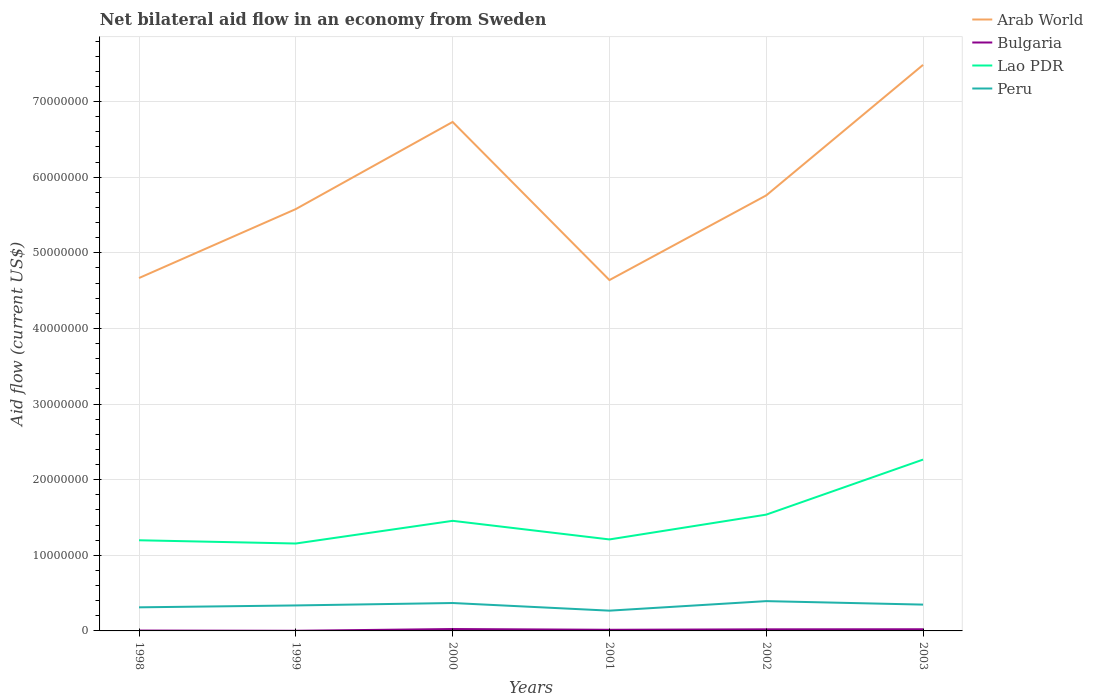How many different coloured lines are there?
Your answer should be very brief. 4. Does the line corresponding to Arab World intersect with the line corresponding to Lao PDR?
Provide a succinct answer. No. Is the number of lines equal to the number of legend labels?
Ensure brevity in your answer.  Yes. Across all years, what is the maximum net bilateral aid flow in Bulgaria?
Offer a terse response. 2.00e+04. What is the total net bilateral aid flow in Lao PDR in the graph?
Make the answer very short. -2.57e+06. What is the difference between the highest and the second highest net bilateral aid flow in Peru?
Give a very brief answer. 1.26e+06. What is the difference between the highest and the lowest net bilateral aid flow in Arab World?
Your response must be concise. 2. Is the net bilateral aid flow in Arab World strictly greater than the net bilateral aid flow in Peru over the years?
Your answer should be compact. No. How many lines are there?
Make the answer very short. 4. What is the difference between two consecutive major ticks on the Y-axis?
Offer a very short reply. 1.00e+07. Are the values on the major ticks of Y-axis written in scientific E-notation?
Your response must be concise. No. Does the graph contain grids?
Your answer should be compact. Yes. Where does the legend appear in the graph?
Ensure brevity in your answer.  Top right. How are the legend labels stacked?
Keep it short and to the point. Vertical. What is the title of the graph?
Offer a very short reply. Net bilateral aid flow in an economy from Sweden. Does "Sri Lanka" appear as one of the legend labels in the graph?
Provide a short and direct response. No. What is the label or title of the Y-axis?
Offer a very short reply. Aid flow (current US$). What is the Aid flow (current US$) in Arab World in 1998?
Offer a very short reply. 4.67e+07. What is the Aid flow (current US$) of Lao PDR in 1998?
Provide a short and direct response. 1.20e+07. What is the Aid flow (current US$) in Peru in 1998?
Offer a very short reply. 3.12e+06. What is the Aid flow (current US$) of Arab World in 1999?
Offer a very short reply. 5.58e+07. What is the Aid flow (current US$) in Lao PDR in 1999?
Your answer should be very brief. 1.16e+07. What is the Aid flow (current US$) in Peru in 1999?
Keep it short and to the point. 3.37e+06. What is the Aid flow (current US$) of Arab World in 2000?
Provide a succinct answer. 6.73e+07. What is the Aid flow (current US$) in Bulgaria in 2000?
Offer a very short reply. 2.50e+05. What is the Aid flow (current US$) in Lao PDR in 2000?
Your response must be concise. 1.46e+07. What is the Aid flow (current US$) of Peru in 2000?
Offer a very short reply. 3.69e+06. What is the Aid flow (current US$) in Arab World in 2001?
Give a very brief answer. 4.64e+07. What is the Aid flow (current US$) in Lao PDR in 2001?
Your answer should be very brief. 1.21e+07. What is the Aid flow (current US$) in Peru in 2001?
Offer a very short reply. 2.68e+06. What is the Aid flow (current US$) of Arab World in 2002?
Offer a terse response. 5.76e+07. What is the Aid flow (current US$) in Lao PDR in 2002?
Give a very brief answer. 1.54e+07. What is the Aid flow (current US$) of Peru in 2002?
Your answer should be compact. 3.94e+06. What is the Aid flow (current US$) of Arab World in 2003?
Give a very brief answer. 7.49e+07. What is the Aid flow (current US$) in Lao PDR in 2003?
Offer a very short reply. 2.27e+07. What is the Aid flow (current US$) of Peru in 2003?
Keep it short and to the point. 3.48e+06. Across all years, what is the maximum Aid flow (current US$) in Arab World?
Offer a terse response. 7.49e+07. Across all years, what is the maximum Aid flow (current US$) of Bulgaria?
Provide a short and direct response. 2.50e+05. Across all years, what is the maximum Aid flow (current US$) of Lao PDR?
Your response must be concise. 2.27e+07. Across all years, what is the maximum Aid flow (current US$) in Peru?
Offer a very short reply. 3.94e+06. Across all years, what is the minimum Aid flow (current US$) in Arab World?
Your answer should be compact. 4.64e+07. Across all years, what is the minimum Aid flow (current US$) of Bulgaria?
Your answer should be compact. 2.00e+04. Across all years, what is the minimum Aid flow (current US$) of Lao PDR?
Ensure brevity in your answer.  1.16e+07. Across all years, what is the minimum Aid flow (current US$) in Peru?
Keep it short and to the point. 2.68e+06. What is the total Aid flow (current US$) in Arab World in the graph?
Ensure brevity in your answer.  3.49e+08. What is the total Aid flow (current US$) in Bulgaria in the graph?
Give a very brief answer. 9.00e+05. What is the total Aid flow (current US$) of Lao PDR in the graph?
Offer a very short reply. 8.82e+07. What is the total Aid flow (current US$) of Peru in the graph?
Give a very brief answer. 2.03e+07. What is the difference between the Aid flow (current US$) in Arab World in 1998 and that in 1999?
Make the answer very short. -9.12e+06. What is the difference between the Aid flow (current US$) in Bulgaria in 1998 and that in 1999?
Offer a terse response. 3.00e+04. What is the difference between the Aid flow (current US$) of Lao PDR in 1998 and that in 1999?
Provide a short and direct response. 4.30e+05. What is the difference between the Aid flow (current US$) of Peru in 1998 and that in 1999?
Provide a succinct answer. -2.50e+05. What is the difference between the Aid flow (current US$) in Arab World in 1998 and that in 2000?
Ensure brevity in your answer.  -2.06e+07. What is the difference between the Aid flow (current US$) in Bulgaria in 1998 and that in 2000?
Offer a very short reply. -2.00e+05. What is the difference between the Aid flow (current US$) of Lao PDR in 1998 and that in 2000?
Give a very brief answer. -2.57e+06. What is the difference between the Aid flow (current US$) in Peru in 1998 and that in 2000?
Offer a very short reply. -5.70e+05. What is the difference between the Aid flow (current US$) of Lao PDR in 1998 and that in 2001?
Your answer should be very brief. -1.10e+05. What is the difference between the Aid flow (current US$) of Arab World in 1998 and that in 2002?
Your answer should be very brief. -1.09e+07. What is the difference between the Aid flow (current US$) of Lao PDR in 1998 and that in 2002?
Offer a very short reply. -3.39e+06. What is the difference between the Aid flow (current US$) in Peru in 1998 and that in 2002?
Keep it short and to the point. -8.20e+05. What is the difference between the Aid flow (current US$) of Arab World in 1998 and that in 2003?
Provide a succinct answer. -2.82e+07. What is the difference between the Aid flow (current US$) in Bulgaria in 1998 and that in 2003?
Provide a short and direct response. -1.70e+05. What is the difference between the Aid flow (current US$) in Lao PDR in 1998 and that in 2003?
Your response must be concise. -1.07e+07. What is the difference between the Aid flow (current US$) in Peru in 1998 and that in 2003?
Offer a very short reply. -3.60e+05. What is the difference between the Aid flow (current US$) of Arab World in 1999 and that in 2000?
Your answer should be compact. -1.15e+07. What is the difference between the Aid flow (current US$) of Lao PDR in 1999 and that in 2000?
Offer a very short reply. -3.00e+06. What is the difference between the Aid flow (current US$) in Peru in 1999 and that in 2000?
Provide a short and direct response. -3.20e+05. What is the difference between the Aid flow (current US$) in Arab World in 1999 and that in 2001?
Make the answer very short. 9.39e+06. What is the difference between the Aid flow (current US$) of Lao PDR in 1999 and that in 2001?
Your response must be concise. -5.40e+05. What is the difference between the Aid flow (current US$) in Peru in 1999 and that in 2001?
Give a very brief answer. 6.90e+05. What is the difference between the Aid flow (current US$) in Arab World in 1999 and that in 2002?
Keep it short and to the point. -1.81e+06. What is the difference between the Aid flow (current US$) of Lao PDR in 1999 and that in 2002?
Give a very brief answer. -3.82e+06. What is the difference between the Aid flow (current US$) of Peru in 1999 and that in 2002?
Provide a succinct answer. -5.70e+05. What is the difference between the Aid flow (current US$) in Arab World in 1999 and that in 2003?
Keep it short and to the point. -1.91e+07. What is the difference between the Aid flow (current US$) in Bulgaria in 1999 and that in 2003?
Your response must be concise. -2.00e+05. What is the difference between the Aid flow (current US$) in Lao PDR in 1999 and that in 2003?
Offer a very short reply. -1.11e+07. What is the difference between the Aid flow (current US$) of Arab World in 2000 and that in 2001?
Your answer should be compact. 2.09e+07. What is the difference between the Aid flow (current US$) in Bulgaria in 2000 and that in 2001?
Keep it short and to the point. 1.00e+05. What is the difference between the Aid flow (current US$) of Lao PDR in 2000 and that in 2001?
Offer a very short reply. 2.46e+06. What is the difference between the Aid flow (current US$) of Peru in 2000 and that in 2001?
Offer a terse response. 1.01e+06. What is the difference between the Aid flow (current US$) in Arab World in 2000 and that in 2002?
Ensure brevity in your answer.  9.71e+06. What is the difference between the Aid flow (current US$) in Bulgaria in 2000 and that in 2002?
Keep it short and to the point. 4.00e+04. What is the difference between the Aid flow (current US$) of Lao PDR in 2000 and that in 2002?
Offer a very short reply. -8.20e+05. What is the difference between the Aid flow (current US$) of Arab World in 2000 and that in 2003?
Your answer should be compact. -7.55e+06. What is the difference between the Aid flow (current US$) in Bulgaria in 2000 and that in 2003?
Give a very brief answer. 3.00e+04. What is the difference between the Aid flow (current US$) of Lao PDR in 2000 and that in 2003?
Your answer should be compact. -8.10e+06. What is the difference between the Aid flow (current US$) of Arab World in 2001 and that in 2002?
Make the answer very short. -1.12e+07. What is the difference between the Aid flow (current US$) in Bulgaria in 2001 and that in 2002?
Keep it short and to the point. -6.00e+04. What is the difference between the Aid flow (current US$) in Lao PDR in 2001 and that in 2002?
Your answer should be compact. -3.28e+06. What is the difference between the Aid flow (current US$) of Peru in 2001 and that in 2002?
Your answer should be compact. -1.26e+06. What is the difference between the Aid flow (current US$) of Arab World in 2001 and that in 2003?
Keep it short and to the point. -2.85e+07. What is the difference between the Aid flow (current US$) in Bulgaria in 2001 and that in 2003?
Your response must be concise. -7.00e+04. What is the difference between the Aid flow (current US$) of Lao PDR in 2001 and that in 2003?
Your response must be concise. -1.06e+07. What is the difference between the Aid flow (current US$) in Peru in 2001 and that in 2003?
Your response must be concise. -8.00e+05. What is the difference between the Aid flow (current US$) in Arab World in 2002 and that in 2003?
Give a very brief answer. -1.73e+07. What is the difference between the Aid flow (current US$) in Bulgaria in 2002 and that in 2003?
Your answer should be very brief. -10000. What is the difference between the Aid flow (current US$) of Lao PDR in 2002 and that in 2003?
Provide a succinct answer. -7.28e+06. What is the difference between the Aid flow (current US$) in Arab World in 1998 and the Aid flow (current US$) in Bulgaria in 1999?
Your response must be concise. 4.66e+07. What is the difference between the Aid flow (current US$) of Arab World in 1998 and the Aid flow (current US$) of Lao PDR in 1999?
Offer a very short reply. 3.51e+07. What is the difference between the Aid flow (current US$) of Arab World in 1998 and the Aid flow (current US$) of Peru in 1999?
Provide a short and direct response. 4.33e+07. What is the difference between the Aid flow (current US$) of Bulgaria in 1998 and the Aid flow (current US$) of Lao PDR in 1999?
Give a very brief answer. -1.15e+07. What is the difference between the Aid flow (current US$) in Bulgaria in 1998 and the Aid flow (current US$) in Peru in 1999?
Offer a very short reply. -3.32e+06. What is the difference between the Aid flow (current US$) of Lao PDR in 1998 and the Aid flow (current US$) of Peru in 1999?
Your answer should be compact. 8.62e+06. What is the difference between the Aid flow (current US$) in Arab World in 1998 and the Aid flow (current US$) in Bulgaria in 2000?
Offer a very short reply. 4.64e+07. What is the difference between the Aid flow (current US$) in Arab World in 1998 and the Aid flow (current US$) in Lao PDR in 2000?
Keep it short and to the point. 3.21e+07. What is the difference between the Aid flow (current US$) of Arab World in 1998 and the Aid flow (current US$) of Peru in 2000?
Make the answer very short. 4.30e+07. What is the difference between the Aid flow (current US$) of Bulgaria in 1998 and the Aid flow (current US$) of Lao PDR in 2000?
Provide a short and direct response. -1.45e+07. What is the difference between the Aid flow (current US$) in Bulgaria in 1998 and the Aid flow (current US$) in Peru in 2000?
Ensure brevity in your answer.  -3.64e+06. What is the difference between the Aid flow (current US$) in Lao PDR in 1998 and the Aid flow (current US$) in Peru in 2000?
Make the answer very short. 8.30e+06. What is the difference between the Aid flow (current US$) in Arab World in 1998 and the Aid flow (current US$) in Bulgaria in 2001?
Ensure brevity in your answer.  4.65e+07. What is the difference between the Aid flow (current US$) of Arab World in 1998 and the Aid flow (current US$) of Lao PDR in 2001?
Your answer should be compact. 3.46e+07. What is the difference between the Aid flow (current US$) in Arab World in 1998 and the Aid flow (current US$) in Peru in 2001?
Provide a succinct answer. 4.40e+07. What is the difference between the Aid flow (current US$) of Bulgaria in 1998 and the Aid flow (current US$) of Lao PDR in 2001?
Offer a terse response. -1.20e+07. What is the difference between the Aid flow (current US$) of Bulgaria in 1998 and the Aid flow (current US$) of Peru in 2001?
Your answer should be compact. -2.63e+06. What is the difference between the Aid flow (current US$) of Lao PDR in 1998 and the Aid flow (current US$) of Peru in 2001?
Make the answer very short. 9.31e+06. What is the difference between the Aid flow (current US$) in Arab World in 1998 and the Aid flow (current US$) in Bulgaria in 2002?
Offer a very short reply. 4.65e+07. What is the difference between the Aid flow (current US$) in Arab World in 1998 and the Aid flow (current US$) in Lao PDR in 2002?
Provide a short and direct response. 3.13e+07. What is the difference between the Aid flow (current US$) of Arab World in 1998 and the Aid flow (current US$) of Peru in 2002?
Offer a terse response. 4.27e+07. What is the difference between the Aid flow (current US$) of Bulgaria in 1998 and the Aid flow (current US$) of Lao PDR in 2002?
Offer a terse response. -1.53e+07. What is the difference between the Aid flow (current US$) in Bulgaria in 1998 and the Aid flow (current US$) in Peru in 2002?
Provide a short and direct response. -3.89e+06. What is the difference between the Aid flow (current US$) of Lao PDR in 1998 and the Aid flow (current US$) of Peru in 2002?
Offer a very short reply. 8.05e+06. What is the difference between the Aid flow (current US$) of Arab World in 1998 and the Aid flow (current US$) of Bulgaria in 2003?
Your answer should be compact. 4.64e+07. What is the difference between the Aid flow (current US$) of Arab World in 1998 and the Aid flow (current US$) of Lao PDR in 2003?
Keep it short and to the point. 2.40e+07. What is the difference between the Aid flow (current US$) of Arab World in 1998 and the Aid flow (current US$) of Peru in 2003?
Provide a short and direct response. 4.32e+07. What is the difference between the Aid flow (current US$) in Bulgaria in 1998 and the Aid flow (current US$) in Lao PDR in 2003?
Your answer should be very brief. -2.26e+07. What is the difference between the Aid flow (current US$) in Bulgaria in 1998 and the Aid flow (current US$) in Peru in 2003?
Keep it short and to the point. -3.43e+06. What is the difference between the Aid flow (current US$) of Lao PDR in 1998 and the Aid flow (current US$) of Peru in 2003?
Make the answer very short. 8.51e+06. What is the difference between the Aid flow (current US$) in Arab World in 1999 and the Aid flow (current US$) in Bulgaria in 2000?
Offer a terse response. 5.55e+07. What is the difference between the Aid flow (current US$) in Arab World in 1999 and the Aid flow (current US$) in Lao PDR in 2000?
Provide a short and direct response. 4.12e+07. What is the difference between the Aid flow (current US$) of Arab World in 1999 and the Aid flow (current US$) of Peru in 2000?
Offer a terse response. 5.21e+07. What is the difference between the Aid flow (current US$) in Bulgaria in 1999 and the Aid flow (current US$) in Lao PDR in 2000?
Provide a succinct answer. -1.45e+07. What is the difference between the Aid flow (current US$) of Bulgaria in 1999 and the Aid flow (current US$) of Peru in 2000?
Provide a short and direct response. -3.67e+06. What is the difference between the Aid flow (current US$) of Lao PDR in 1999 and the Aid flow (current US$) of Peru in 2000?
Your answer should be very brief. 7.87e+06. What is the difference between the Aid flow (current US$) of Arab World in 1999 and the Aid flow (current US$) of Bulgaria in 2001?
Provide a succinct answer. 5.56e+07. What is the difference between the Aid flow (current US$) of Arab World in 1999 and the Aid flow (current US$) of Lao PDR in 2001?
Offer a very short reply. 4.37e+07. What is the difference between the Aid flow (current US$) of Arab World in 1999 and the Aid flow (current US$) of Peru in 2001?
Offer a terse response. 5.31e+07. What is the difference between the Aid flow (current US$) in Bulgaria in 1999 and the Aid flow (current US$) in Lao PDR in 2001?
Offer a terse response. -1.21e+07. What is the difference between the Aid flow (current US$) of Bulgaria in 1999 and the Aid flow (current US$) of Peru in 2001?
Your answer should be compact. -2.66e+06. What is the difference between the Aid flow (current US$) in Lao PDR in 1999 and the Aid flow (current US$) in Peru in 2001?
Offer a very short reply. 8.88e+06. What is the difference between the Aid flow (current US$) in Arab World in 1999 and the Aid flow (current US$) in Bulgaria in 2002?
Your response must be concise. 5.56e+07. What is the difference between the Aid flow (current US$) of Arab World in 1999 and the Aid flow (current US$) of Lao PDR in 2002?
Give a very brief answer. 4.04e+07. What is the difference between the Aid flow (current US$) of Arab World in 1999 and the Aid flow (current US$) of Peru in 2002?
Offer a very short reply. 5.18e+07. What is the difference between the Aid flow (current US$) in Bulgaria in 1999 and the Aid flow (current US$) in Lao PDR in 2002?
Give a very brief answer. -1.54e+07. What is the difference between the Aid flow (current US$) of Bulgaria in 1999 and the Aid flow (current US$) of Peru in 2002?
Offer a very short reply. -3.92e+06. What is the difference between the Aid flow (current US$) in Lao PDR in 1999 and the Aid flow (current US$) in Peru in 2002?
Your answer should be compact. 7.62e+06. What is the difference between the Aid flow (current US$) in Arab World in 1999 and the Aid flow (current US$) in Bulgaria in 2003?
Give a very brief answer. 5.56e+07. What is the difference between the Aid flow (current US$) of Arab World in 1999 and the Aid flow (current US$) of Lao PDR in 2003?
Ensure brevity in your answer.  3.31e+07. What is the difference between the Aid flow (current US$) in Arab World in 1999 and the Aid flow (current US$) in Peru in 2003?
Offer a very short reply. 5.23e+07. What is the difference between the Aid flow (current US$) in Bulgaria in 1999 and the Aid flow (current US$) in Lao PDR in 2003?
Your answer should be compact. -2.26e+07. What is the difference between the Aid flow (current US$) of Bulgaria in 1999 and the Aid flow (current US$) of Peru in 2003?
Your response must be concise. -3.46e+06. What is the difference between the Aid flow (current US$) in Lao PDR in 1999 and the Aid flow (current US$) in Peru in 2003?
Provide a short and direct response. 8.08e+06. What is the difference between the Aid flow (current US$) of Arab World in 2000 and the Aid flow (current US$) of Bulgaria in 2001?
Your answer should be compact. 6.72e+07. What is the difference between the Aid flow (current US$) of Arab World in 2000 and the Aid flow (current US$) of Lao PDR in 2001?
Give a very brief answer. 5.52e+07. What is the difference between the Aid flow (current US$) of Arab World in 2000 and the Aid flow (current US$) of Peru in 2001?
Ensure brevity in your answer.  6.46e+07. What is the difference between the Aid flow (current US$) in Bulgaria in 2000 and the Aid flow (current US$) in Lao PDR in 2001?
Your answer should be compact. -1.18e+07. What is the difference between the Aid flow (current US$) of Bulgaria in 2000 and the Aid flow (current US$) of Peru in 2001?
Provide a short and direct response. -2.43e+06. What is the difference between the Aid flow (current US$) in Lao PDR in 2000 and the Aid flow (current US$) in Peru in 2001?
Ensure brevity in your answer.  1.19e+07. What is the difference between the Aid flow (current US$) of Arab World in 2000 and the Aid flow (current US$) of Bulgaria in 2002?
Provide a short and direct response. 6.71e+07. What is the difference between the Aid flow (current US$) of Arab World in 2000 and the Aid flow (current US$) of Lao PDR in 2002?
Give a very brief answer. 5.19e+07. What is the difference between the Aid flow (current US$) in Arab World in 2000 and the Aid flow (current US$) in Peru in 2002?
Make the answer very short. 6.34e+07. What is the difference between the Aid flow (current US$) in Bulgaria in 2000 and the Aid flow (current US$) in Lao PDR in 2002?
Give a very brief answer. -1.51e+07. What is the difference between the Aid flow (current US$) of Bulgaria in 2000 and the Aid flow (current US$) of Peru in 2002?
Offer a very short reply. -3.69e+06. What is the difference between the Aid flow (current US$) of Lao PDR in 2000 and the Aid flow (current US$) of Peru in 2002?
Provide a short and direct response. 1.06e+07. What is the difference between the Aid flow (current US$) in Arab World in 2000 and the Aid flow (current US$) in Bulgaria in 2003?
Ensure brevity in your answer.  6.71e+07. What is the difference between the Aid flow (current US$) in Arab World in 2000 and the Aid flow (current US$) in Lao PDR in 2003?
Offer a terse response. 4.46e+07. What is the difference between the Aid flow (current US$) in Arab World in 2000 and the Aid flow (current US$) in Peru in 2003?
Provide a short and direct response. 6.38e+07. What is the difference between the Aid flow (current US$) of Bulgaria in 2000 and the Aid flow (current US$) of Lao PDR in 2003?
Make the answer very short. -2.24e+07. What is the difference between the Aid flow (current US$) of Bulgaria in 2000 and the Aid flow (current US$) of Peru in 2003?
Ensure brevity in your answer.  -3.23e+06. What is the difference between the Aid flow (current US$) of Lao PDR in 2000 and the Aid flow (current US$) of Peru in 2003?
Keep it short and to the point. 1.11e+07. What is the difference between the Aid flow (current US$) of Arab World in 2001 and the Aid flow (current US$) of Bulgaria in 2002?
Provide a short and direct response. 4.62e+07. What is the difference between the Aid flow (current US$) of Arab World in 2001 and the Aid flow (current US$) of Lao PDR in 2002?
Make the answer very short. 3.10e+07. What is the difference between the Aid flow (current US$) in Arab World in 2001 and the Aid flow (current US$) in Peru in 2002?
Your answer should be compact. 4.25e+07. What is the difference between the Aid flow (current US$) in Bulgaria in 2001 and the Aid flow (current US$) in Lao PDR in 2002?
Offer a terse response. -1.52e+07. What is the difference between the Aid flow (current US$) of Bulgaria in 2001 and the Aid flow (current US$) of Peru in 2002?
Provide a short and direct response. -3.79e+06. What is the difference between the Aid flow (current US$) of Lao PDR in 2001 and the Aid flow (current US$) of Peru in 2002?
Provide a succinct answer. 8.16e+06. What is the difference between the Aid flow (current US$) in Arab World in 2001 and the Aid flow (current US$) in Bulgaria in 2003?
Provide a short and direct response. 4.62e+07. What is the difference between the Aid flow (current US$) of Arab World in 2001 and the Aid flow (current US$) of Lao PDR in 2003?
Give a very brief answer. 2.37e+07. What is the difference between the Aid flow (current US$) in Arab World in 2001 and the Aid flow (current US$) in Peru in 2003?
Offer a very short reply. 4.29e+07. What is the difference between the Aid flow (current US$) of Bulgaria in 2001 and the Aid flow (current US$) of Lao PDR in 2003?
Offer a very short reply. -2.25e+07. What is the difference between the Aid flow (current US$) of Bulgaria in 2001 and the Aid flow (current US$) of Peru in 2003?
Offer a very short reply. -3.33e+06. What is the difference between the Aid flow (current US$) of Lao PDR in 2001 and the Aid flow (current US$) of Peru in 2003?
Provide a succinct answer. 8.62e+06. What is the difference between the Aid flow (current US$) of Arab World in 2002 and the Aid flow (current US$) of Bulgaria in 2003?
Provide a succinct answer. 5.74e+07. What is the difference between the Aid flow (current US$) in Arab World in 2002 and the Aid flow (current US$) in Lao PDR in 2003?
Ensure brevity in your answer.  3.49e+07. What is the difference between the Aid flow (current US$) of Arab World in 2002 and the Aid flow (current US$) of Peru in 2003?
Provide a succinct answer. 5.41e+07. What is the difference between the Aid flow (current US$) of Bulgaria in 2002 and the Aid flow (current US$) of Lao PDR in 2003?
Keep it short and to the point. -2.24e+07. What is the difference between the Aid flow (current US$) in Bulgaria in 2002 and the Aid flow (current US$) in Peru in 2003?
Make the answer very short. -3.27e+06. What is the difference between the Aid flow (current US$) in Lao PDR in 2002 and the Aid flow (current US$) in Peru in 2003?
Offer a terse response. 1.19e+07. What is the average Aid flow (current US$) of Arab World per year?
Offer a terse response. 5.81e+07. What is the average Aid flow (current US$) of Bulgaria per year?
Provide a succinct answer. 1.50e+05. What is the average Aid flow (current US$) of Lao PDR per year?
Offer a terse response. 1.47e+07. What is the average Aid flow (current US$) of Peru per year?
Offer a terse response. 3.38e+06. In the year 1998, what is the difference between the Aid flow (current US$) in Arab World and Aid flow (current US$) in Bulgaria?
Offer a terse response. 4.66e+07. In the year 1998, what is the difference between the Aid flow (current US$) of Arab World and Aid flow (current US$) of Lao PDR?
Keep it short and to the point. 3.47e+07. In the year 1998, what is the difference between the Aid flow (current US$) of Arab World and Aid flow (current US$) of Peru?
Your answer should be compact. 4.36e+07. In the year 1998, what is the difference between the Aid flow (current US$) in Bulgaria and Aid flow (current US$) in Lao PDR?
Keep it short and to the point. -1.19e+07. In the year 1998, what is the difference between the Aid flow (current US$) in Bulgaria and Aid flow (current US$) in Peru?
Your response must be concise. -3.07e+06. In the year 1998, what is the difference between the Aid flow (current US$) of Lao PDR and Aid flow (current US$) of Peru?
Offer a very short reply. 8.87e+06. In the year 1999, what is the difference between the Aid flow (current US$) in Arab World and Aid flow (current US$) in Bulgaria?
Your answer should be compact. 5.58e+07. In the year 1999, what is the difference between the Aid flow (current US$) of Arab World and Aid flow (current US$) of Lao PDR?
Make the answer very short. 4.42e+07. In the year 1999, what is the difference between the Aid flow (current US$) in Arab World and Aid flow (current US$) in Peru?
Provide a short and direct response. 5.24e+07. In the year 1999, what is the difference between the Aid flow (current US$) of Bulgaria and Aid flow (current US$) of Lao PDR?
Offer a very short reply. -1.15e+07. In the year 1999, what is the difference between the Aid flow (current US$) of Bulgaria and Aid flow (current US$) of Peru?
Your response must be concise. -3.35e+06. In the year 1999, what is the difference between the Aid flow (current US$) in Lao PDR and Aid flow (current US$) in Peru?
Give a very brief answer. 8.19e+06. In the year 2000, what is the difference between the Aid flow (current US$) in Arab World and Aid flow (current US$) in Bulgaria?
Ensure brevity in your answer.  6.71e+07. In the year 2000, what is the difference between the Aid flow (current US$) of Arab World and Aid flow (current US$) of Lao PDR?
Provide a short and direct response. 5.28e+07. In the year 2000, what is the difference between the Aid flow (current US$) of Arab World and Aid flow (current US$) of Peru?
Make the answer very short. 6.36e+07. In the year 2000, what is the difference between the Aid flow (current US$) of Bulgaria and Aid flow (current US$) of Lao PDR?
Ensure brevity in your answer.  -1.43e+07. In the year 2000, what is the difference between the Aid flow (current US$) in Bulgaria and Aid flow (current US$) in Peru?
Your answer should be very brief. -3.44e+06. In the year 2000, what is the difference between the Aid flow (current US$) of Lao PDR and Aid flow (current US$) of Peru?
Offer a terse response. 1.09e+07. In the year 2001, what is the difference between the Aid flow (current US$) of Arab World and Aid flow (current US$) of Bulgaria?
Your response must be concise. 4.62e+07. In the year 2001, what is the difference between the Aid flow (current US$) in Arab World and Aid flow (current US$) in Lao PDR?
Provide a short and direct response. 3.43e+07. In the year 2001, what is the difference between the Aid flow (current US$) of Arab World and Aid flow (current US$) of Peru?
Give a very brief answer. 4.37e+07. In the year 2001, what is the difference between the Aid flow (current US$) in Bulgaria and Aid flow (current US$) in Lao PDR?
Give a very brief answer. -1.20e+07. In the year 2001, what is the difference between the Aid flow (current US$) in Bulgaria and Aid flow (current US$) in Peru?
Keep it short and to the point. -2.53e+06. In the year 2001, what is the difference between the Aid flow (current US$) in Lao PDR and Aid flow (current US$) in Peru?
Give a very brief answer. 9.42e+06. In the year 2002, what is the difference between the Aid flow (current US$) of Arab World and Aid flow (current US$) of Bulgaria?
Give a very brief answer. 5.74e+07. In the year 2002, what is the difference between the Aid flow (current US$) of Arab World and Aid flow (current US$) of Lao PDR?
Offer a terse response. 4.22e+07. In the year 2002, what is the difference between the Aid flow (current US$) in Arab World and Aid flow (current US$) in Peru?
Offer a very short reply. 5.37e+07. In the year 2002, what is the difference between the Aid flow (current US$) of Bulgaria and Aid flow (current US$) of Lao PDR?
Ensure brevity in your answer.  -1.52e+07. In the year 2002, what is the difference between the Aid flow (current US$) in Bulgaria and Aid flow (current US$) in Peru?
Ensure brevity in your answer.  -3.73e+06. In the year 2002, what is the difference between the Aid flow (current US$) in Lao PDR and Aid flow (current US$) in Peru?
Ensure brevity in your answer.  1.14e+07. In the year 2003, what is the difference between the Aid flow (current US$) of Arab World and Aid flow (current US$) of Bulgaria?
Offer a very short reply. 7.46e+07. In the year 2003, what is the difference between the Aid flow (current US$) of Arab World and Aid flow (current US$) of Lao PDR?
Offer a very short reply. 5.22e+07. In the year 2003, what is the difference between the Aid flow (current US$) in Arab World and Aid flow (current US$) in Peru?
Make the answer very short. 7.14e+07. In the year 2003, what is the difference between the Aid flow (current US$) in Bulgaria and Aid flow (current US$) in Lao PDR?
Your answer should be compact. -2.24e+07. In the year 2003, what is the difference between the Aid flow (current US$) of Bulgaria and Aid flow (current US$) of Peru?
Offer a terse response. -3.26e+06. In the year 2003, what is the difference between the Aid flow (current US$) of Lao PDR and Aid flow (current US$) of Peru?
Your response must be concise. 1.92e+07. What is the ratio of the Aid flow (current US$) in Arab World in 1998 to that in 1999?
Provide a succinct answer. 0.84. What is the ratio of the Aid flow (current US$) of Bulgaria in 1998 to that in 1999?
Provide a succinct answer. 2.5. What is the ratio of the Aid flow (current US$) in Lao PDR in 1998 to that in 1999?
Your answer should be compact. 1.04. What is the ratio of the Aid flow (current US$) in Peru in 1998 to that in 1999?
Your answer should be very brief. 0.93. What is the ratio of the Aid flow (current US$) of Arab World in 1998 to that in 2000?
Give a very brief answer. 0.69. What is the ratio of the Aid flow (current US$) in Bulgaria in 1998 to that in 2000?
Provide a short and direct response. 0.2. What is the ratio of the Aid flow (current US$) of Lao PDR in 1998 to that in 2000?
Provide a short and direct response. 0.82. What is the ratio of the Aid flow (current US$) of Peru in 1998 to that in 2000?
Make the answer very short. 0.85. What is the ratio of the Aid flow (current US$) of Lao PDR in 1998 to that in 2001?
Give a very brief answer. 0.99. What is the ratio of the Aid flow (current US$) of Peru in 1998 to that in 2001?
Ensure brevity in your answer.  1.16. What is the ratio of the Aid flow (current US$) of Arab World in 1998 to that in 2002?
Your response must be concise. 0.81. What is the ratio of the Aid flow (current US$) in Bulgaria in 1998 to that in 2002?
Provide a succinct answer. 0.24. What is the ratio of the Aid flow (current US$) of Lao PDR in 1998 to that in 2002?
Ensure brevity in your answer.  0.78. What is the ratio of the Aid flow (current US$) of Peru in 1998 to that in 2002?
Provide a short and direct response. 0.79. What is the ratio of the Aid flow (current US$) in Arab World in 1998 to that in 2003?
Provide a succinct answer. 0.62. What is the ratio of the Aid flow (current US$) of Bulgaria in 1998 to that in 2003?
Your response must be concise. 0.23. What is the ratio of the Aid flow (current US$) in Lao PDR in 1998 to that in 2003?
Your response must be concise. 0.53. What is the ratio of the Aid flow (current US$) in Peru in 1998 to that in 2003?
Your response must be concise. 0.9. What is the ratio of the Aid flow (current US$) of Arab World in 1999 to that in 2000?
Provide a short and direct response. 0.83. What is the ratio of the Aid flow (current US$) of Lao PDR in 1999 to that in 2000?
Keep it short and to the point. 0.79. What is the ratio of the Aid flow (current US$) of Peru in 1999 to that in 2000?
Offer a very short reply. 0.91. What is the ratio of the Aid flow (current US$) in Arab World in 1999 to that in 2001?
Keep it short and to the point. 1.2. What is the ratio of the Aid flow (current US$) in Bulgaria in 1999 to that in 2001?
Make the answer very short. 0.13. What is the ratio of the Aid flow (current US$) of Lao PDR in 1999 to that in 2001?
Your answer should be compact. 0.96. What is the ratio of the Aid flow (current US$) of Peru in 1999 to that in 2001?
Provide a succinct answer. 1.26. What is the ratio of the Aid flow (current US$) of Arab World in 1999 to that in 2002?
Offer a very short reply. 0.97. What is the ratio of the Aid flow (current US$) in Bulgaria in 1999 to that in 2002?
Make the answer very short. 0.1. What is the ratio of the Aid flow (current US$) of Lao PDR in 1999 to that in 2002?
Offer a very short reply. 0.75. What is the ratio of the Aid flow (current US$) in Peru in 1999 to that in 2002?
Give a very brief answer. 0.86. What is the ratio of the Aid flow (current US$) in Arab World in 1999 to that in 2003?
Offer a very short reply. 0.75. What is the ratio of the Aid flow (current US$) of Bulgaria in 1999 to that in 2003?
Keep it short and to the point. 0.09. What is the ratio of the Aid flow (current US$) of Lao PDR in 1999 to that in 2003?
Your response must be concise. 0.51. What is the ratio of the Aid flow (current US$) in Peru in 1999 to that in 2003?
Offer a terse response. 0.97. What is the ratio of the Aid flow (current US$) of Arab World in 2000 to that in 2001?
Offer a very short reply. 1.45. What is the ratio of the Aid flow (current US$) in Bulgaria in 2000 to that in 2001?
Provide a short and direct response. 1.67. What is the ratio of the Aid flow (current US$) in Lao PDR in 2000 to that in 2001?
Keep it short and to the point. 1.2. What is the ratio of the Aid flow (current US$) of Peru in 2000 to that in 2001?
Make the answer very short. 1.38. What is the ratio of the Aid flow (current US$) of Arab World in 2000 to that in 2002?
Your answer should be compact. 1.17. What is the ratio of the Aid flow (current US$) in Bulgaria in 2000 to that in 2002?
Provide a short and direct response. 1.19. What is the ratio of the Aid flow (current US$) in Lao PDR in 2000 to that in 2002?
Provide a succinct answer. 0.95. What is the ratio of the Aid flow (current US$) of Peru in 2000 to that in 2002?
Offer a terse response. 0.94. What is the ratio of the Aid flow (current US$) of Arab World in 2000 to that in 2003?
Offer a very short reply. 0.9. What is the ratio of the Aid flow (current US$) in Bulgaria in 2000 to that in 2003?
Provide a succinct answer. 1.14. What is the ratio of the Aid flow (current US$) of Lao PDR in 2000 to that in 2003?
Keep it short and to the point. 0.64. What is the ratio of the Aid flow (current US$) of Peru in 2000 to that in 2003?
Keep it short and to the point. 1.06. What is the ratio of the Aid flow (current US$) of Arab World in 2001 to that in 2002?
Your answer should be very brief. 0.81. What is the ratio of the Aid flow (current US$) of Lao PDR in 2001 to that in 2002?
Provide a succinct answer. 0.79. What is the ratio of the Aid flow (current US$) in Peru in 2001 to that in 2002?
Offer a very short reply. 0.68. What is the ratio of the Aid flow (current US$) in Arab World in 2001 to that in 2003?
Provide a short and direct response. 0.62. What is the ratio of the Aid flow (current US$) in Bulgaria in 2001 to that in 2003?
Keep it short and to the point. 0.68. What is the ratio of the Aid flow (current US$) of Lao PDR in 2001 to that in 2003?
Ensure brevity in your answer.  0.53. What is the ratio of the Aid flow (current US$) of Peru in 2001 to that in 2003?
Give a very brief answer. 0.77. What is the ratio of the Aid flow (current US$) of Arab World in 2002 to that in 2003?
Offer a terse response. 0.77. What is the ratio of the Aid flow (current US$) in Bulgaria in 2002 to that in 2003?
Give a very brief answer. 0.95. What is the ratio of the Aid flow (current US$) in Lao PDR in 2002 to that in 2003?
Make the answer very short. 0.68. What is the ratio of the Aid flow (current US$) in Peru in 2002 to that in 2003?
Give a very brief answer. 1.13. What is the difference between the highest and the second highest Aid flow (current US$) of Arab World?
Keep it short and to the point. 7.55e+06. What is the difference between the highest and the second highest Aid flow (current US$) in Lao PDR?
Offer a very short reply. 7.28e+06. What is the difference between the highest and the lowest Aid flow (current US$) in Arab World?
Ensure brevity in your answer.  2.85e+07. What is the difference between the highest and the lowest Aid flow (current US$) in Lao PDR?
Provide a succinct answer. 1.11e+07. What is the difference between the highest and the lowest Aid flow (current US$) in Peru?
Give a very brief answer. 1.26e+06. 